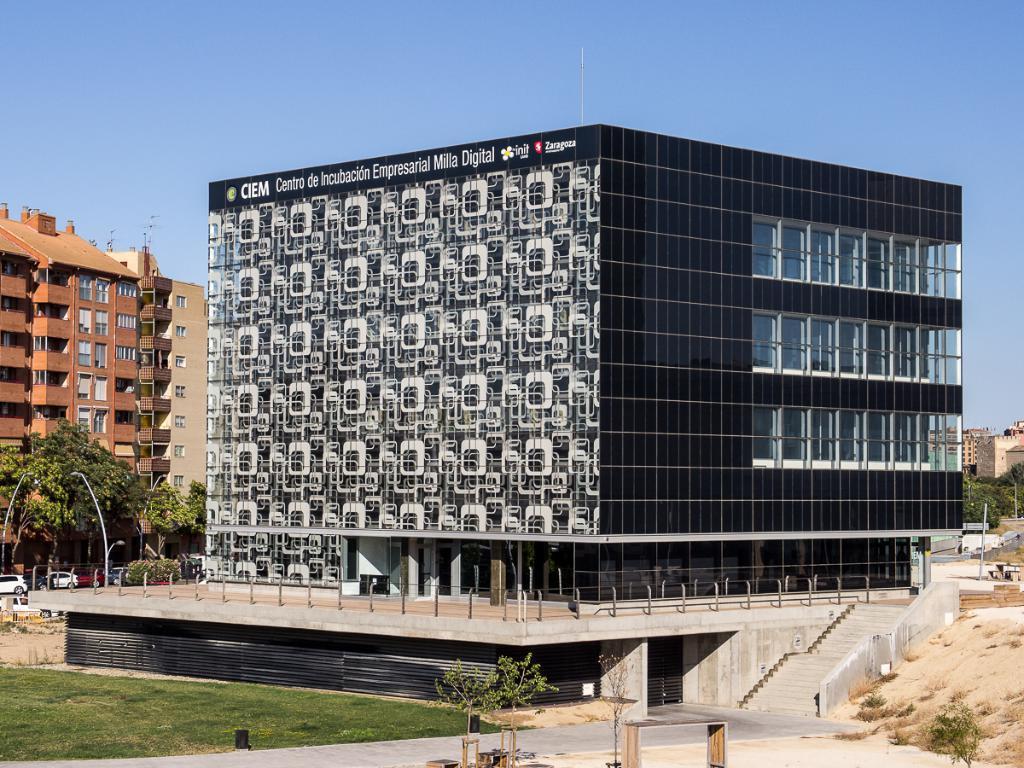Could you give a brief overview of what you see in this image? In this image there are buildings and trees. On the left we can see cars. At the bottom there is grass. On the right there are stairs. In the background there is sky. 